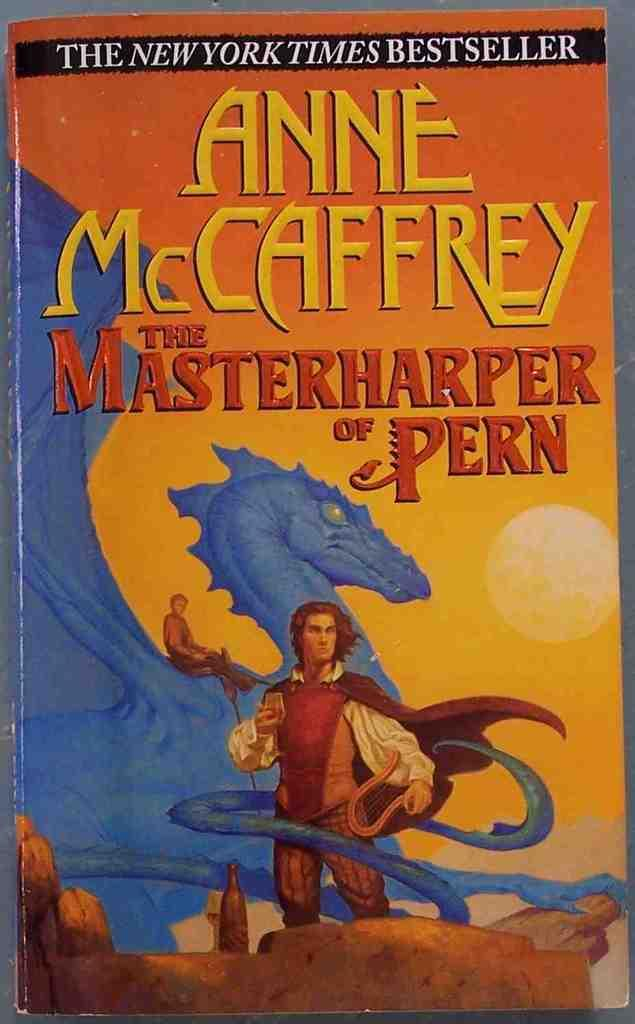<image>
Relay a brief, clear account of the picture shown. a new york times bestseller called 'the masterhapper of pern' 